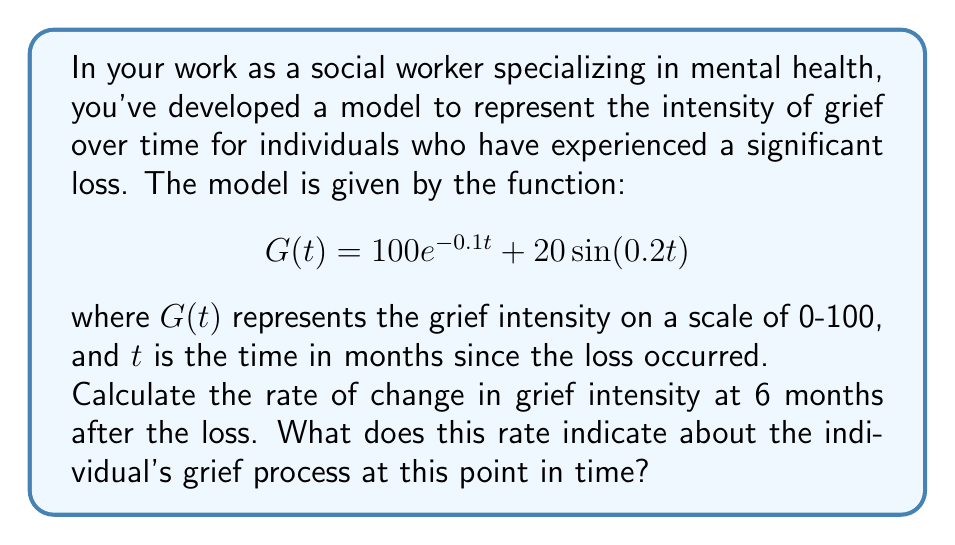Help me with this question. To solve this problem, we need to follow these steps:

1) First, we need to find the derivative of the grief function $G(t)$. This will give us the rate of change of grief intensity over time.

   $$\frac{d}{dt}G(t) = \frac{d}{dt}(100e^{-0.1t} + 20\sin(0.2t))$$

2) Using the rules of differentiation:
   
   $$G'(t) = 100 \cdot (-0.1)e^{-0.1t} + 20 \cdot 0.2\cos(0.2t)$$
   
   $$G'(t) = -10e^{-0.1t} + 4\cos(0.2t)$$

3) Now, we need to evaluate this derivative at t = 6 months:

   $$G'(6) = -10e^{-0.1(6)} + 4\cos(0.2(6))$$

4) Let's calculate each part:
   
   $e^{-0.1(6)} = e^{-0.6} \approx 0.5488$
   
   $\cos(0.2(6)) = \cos(1.2) \approx 0.3624$

5) Substituting these values:

   $$G'(6) = -10(0.5488) + 4(0.3624)$$
   $$G'(6) = -5.488 + 1.4496$$
   $$G'(6) = -4.0384$$

6) Interpreting the result:
   The rate of change at 6 months is approximately -4.0384 units per month. The negative value indicates that the grief intensity is decreasing at this point in time.
Answer: $-4.0384$ units/month, indicating decreasing grief intensity 